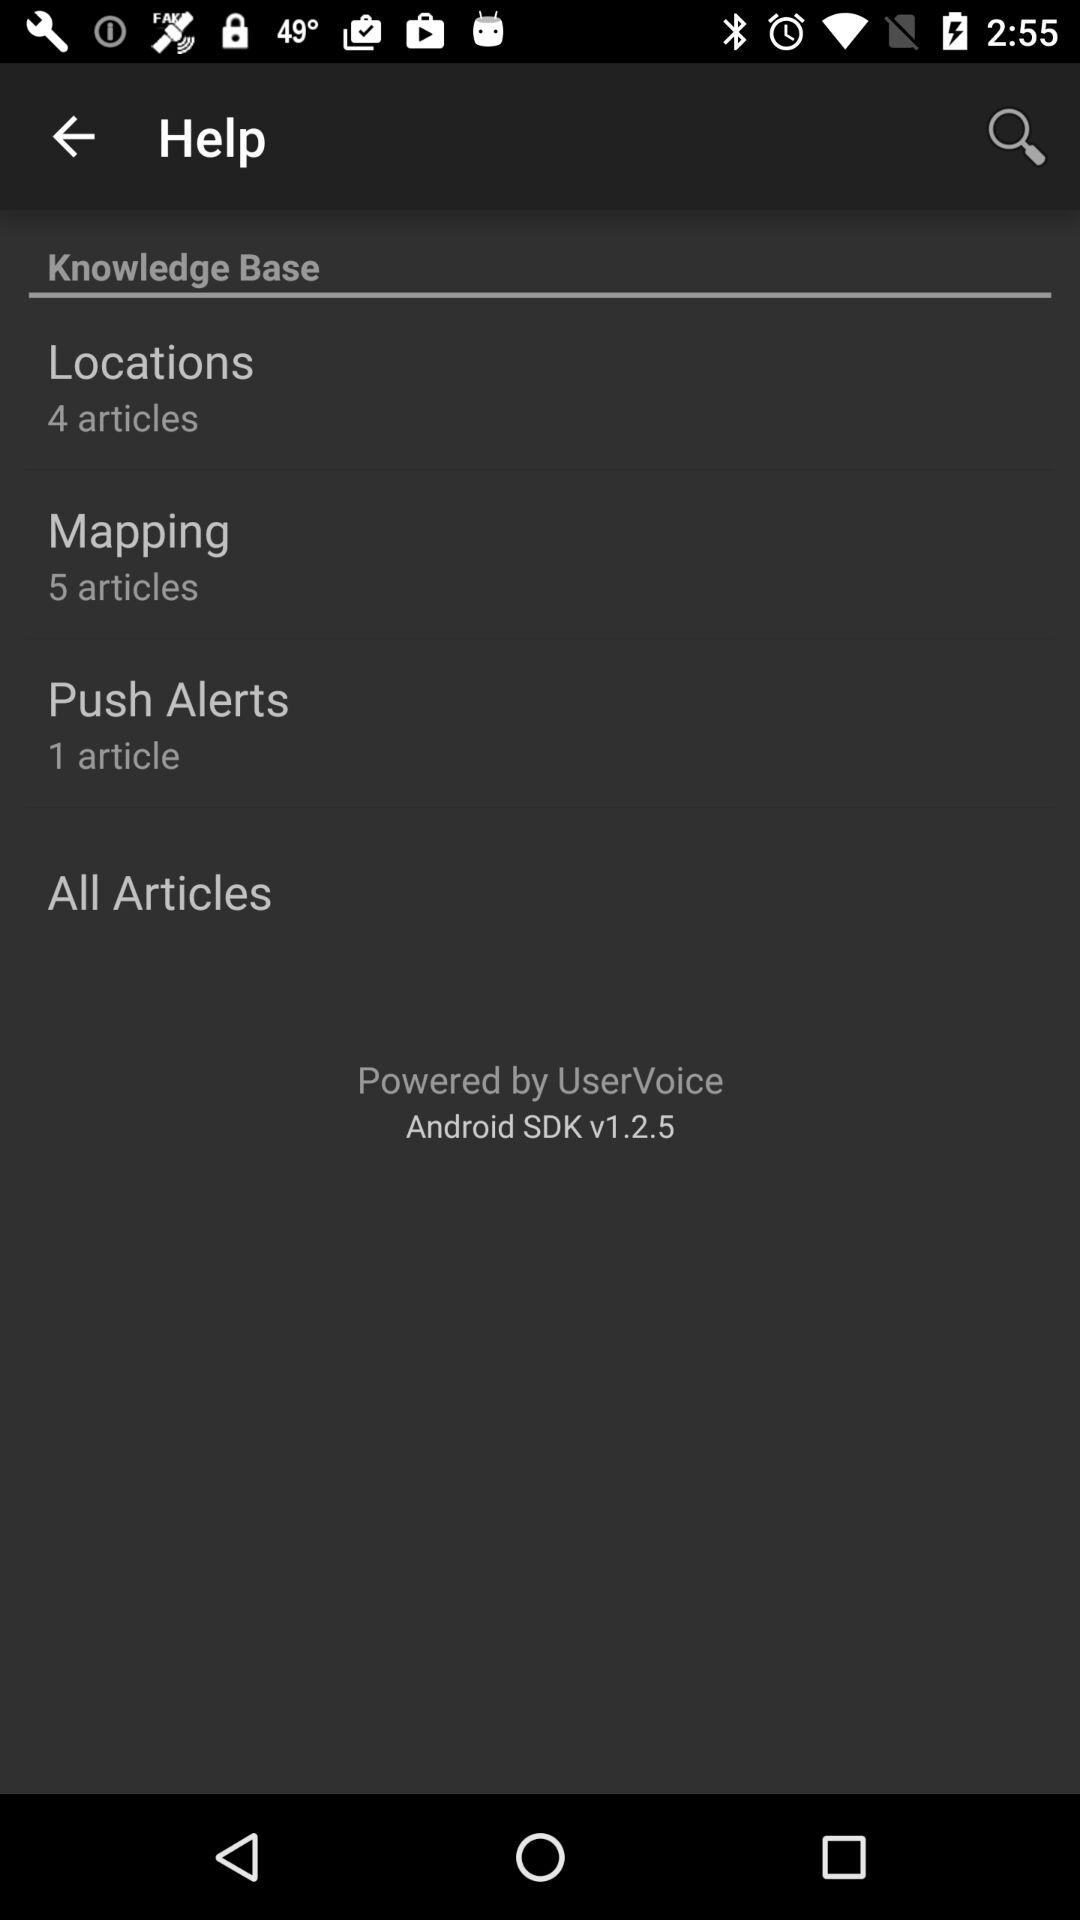How many articles are available in the Mapping category?
Answer the question using a single word or phrase. 5 